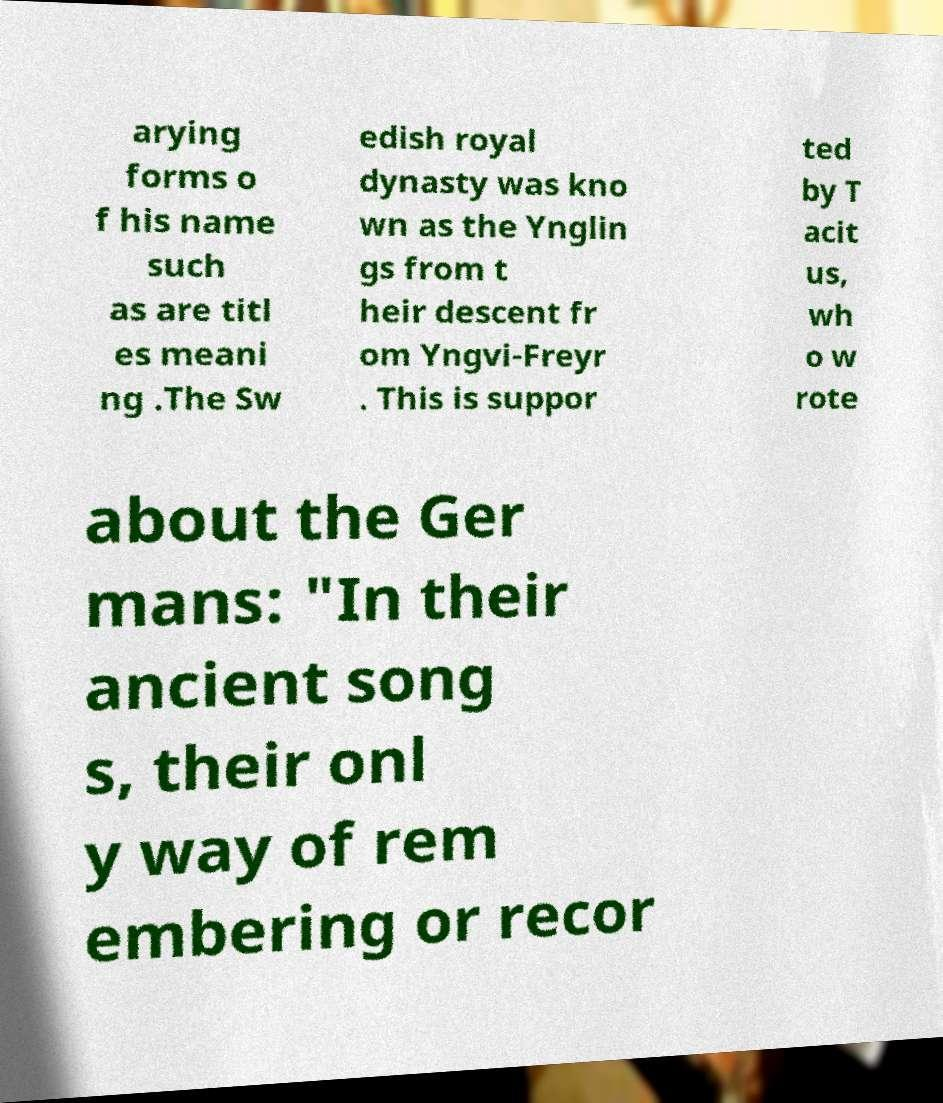Could you assist in decoding the text presented in this image and type it out clearly? arying forms o f his name such as are titl es meani ng .The Sw edish royal dynasty was kno wn as the Ynglin gs from t heir descent fr om Yngvi-Freyr . This is suppor ted by T acit us, wh o w rote about the Ger mans: "In their ancient song s, their onl y way of rem embering or recor 